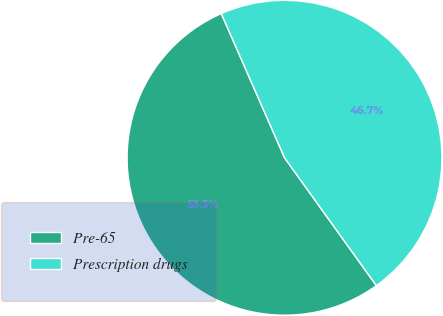Convert chart. <chart><loc_0><loc_0><loc_500><loc_500><pie_chart><fcel>Pre-65<fcel>Prescription drugs<nl><fcel>53.33%<fcel>46.67%<nl></chart> 